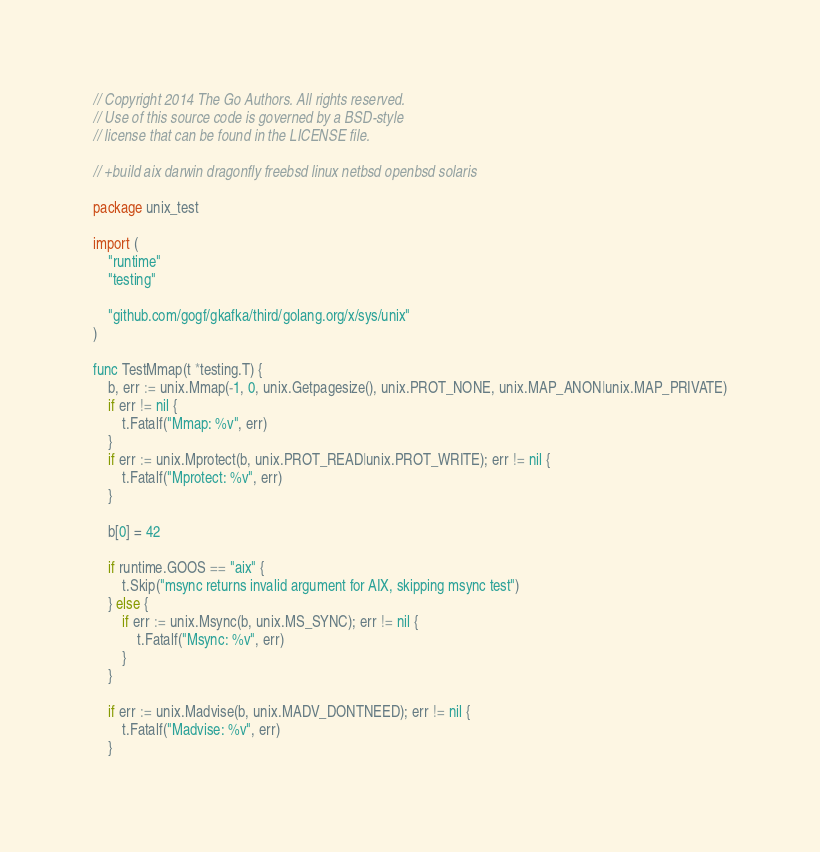Convert code to text. <code><loc_0><loc_0><loc_500><loc_500><_Go_>// Copyright 2014 The Go Authors. All rights reserved.
// Use of this source code is governed by a BSD-style
// license that can be found in the LICENSE file.

// +build aix darwin dragonfly freebsd linux netbsd openbsd solaris

package unix_test

import (
	"runtime"
	"testing"

	"github.com/gogf/gkafka/third/golang.org/x/sys/unix"
)

func TestMmap(t *testing.T) {
	b, err := unix.Mmap(-1, 0, unix.Getpagesize(), unix.PROT_NONE, unix.MAP_ANON|unix.MAP_PRIVATE)
	if err != nil {
		t.Fatalf("Mmap: %v", err)
	}
	if err := unix.Mprotect(b, unix.PROT_READ|unix.PROT_WRITE); err != nil {
		t.Fatalf("Mprotect: %v", err)
	}

	b[0] = 42

	if runtime.GOOS == "aix" {
		t.Skip("msync returns invalid argument for AIX, skipping msync test")
	} else {
		if err := unix.Msync(b, unix.MS_SYNC); err != nil {
			t.Fatalf("Msync: %v", err)
		}
	}

	if err := unix.Madvise(b, unix.MADV_DONTNEED); err != nil {
		t.Fatalf("Madvise: %v", err)
	}</code> 